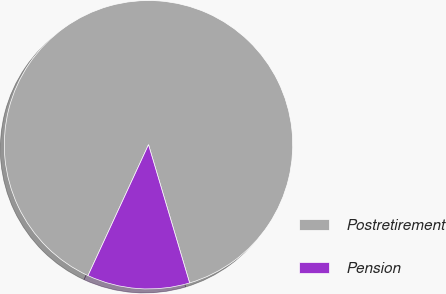Convert chart to OTSL. <chart><loc_0><loc_0><loc_500><loc_500><pie_chart><fcel>Postretirement<fcel>Pension<nl><fcel>88.51%<fcel>11.49%<nl></chart> 